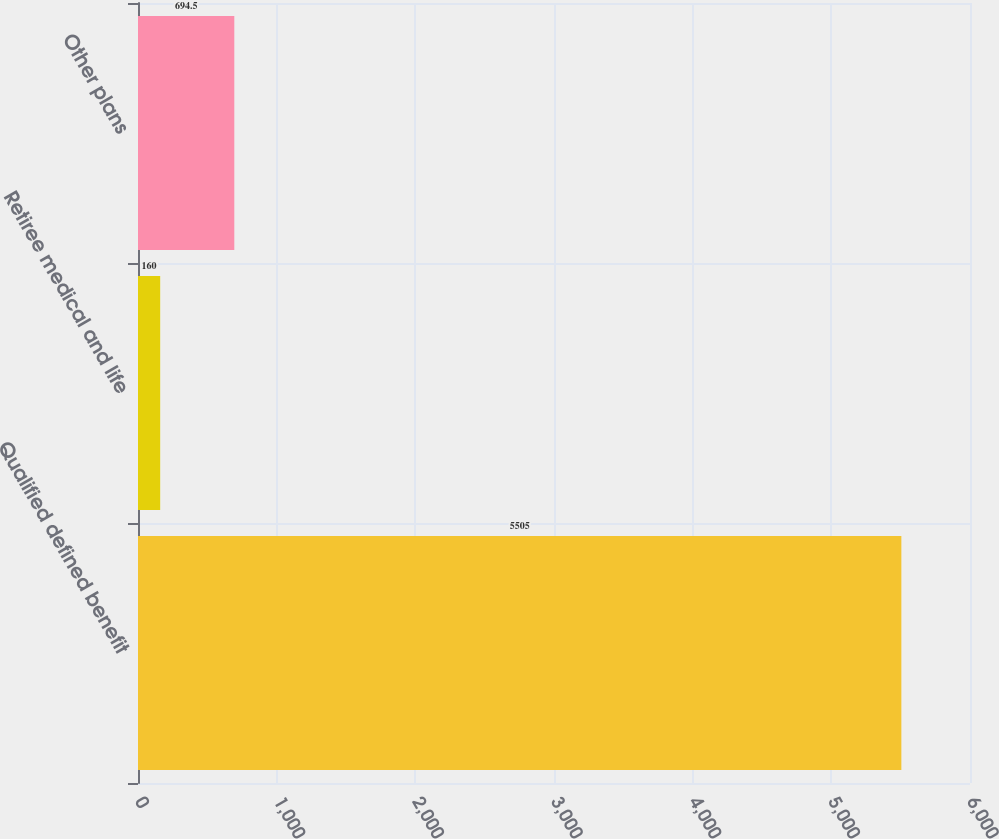Convert chart to OTSL. <chart><loc_0><loc_0><loc_500><loc_500><bar_chart><fcel>Qualified defined benefit<fcel>Retiree medical and life<fcel>Other plans<nl><fcel>5505<fcel>160<fcel>694.5<nl></chart> 